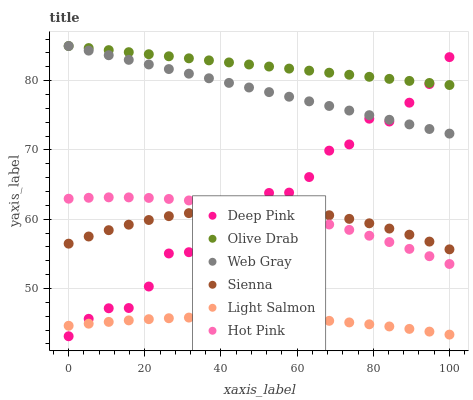Does Light Salmon have the minimum area under the curve?
Answer yes or no. Yes. Does Olive Drab have the maximum area under the curve?
Answer yes or no. Yes. Does Deep Pink have the minimum area under the curve?
Answer yes or no. No. Does Deep Pink have the maximum area under the curve?
Answer yes or no. No. Is Olive Drab the smoothest?
Answer yes or no. Yes. Is Deep Pink the roughest?
Answer yes or no. Yes. Is Hot Pink the smoothest?
Answer yes or no. No. Is Hot Pink the roughest?
Answer yes or no. No. Does Deep Pink have the lowest value?
Answer yes or no. Yes. Does Hot Pink have the lowest value?
Answer yes or no. No. Does Olive Drab have the highest value?
Answer yes or no. Yes. Does Deep Pink have the highest value?
Answer yes or no. No. Is Light Salmon less than Olive Drab?
Answer yes or no. Yes. Is Web Gray greater than Light Salmon?
Answer yes or no. Yes. Does Web Gray intersect Olive Drab?
Answer yes or no. Yes. Is Web Gray less than Olive Drab?
Answer yes or no. No. Is Web Gray greater than Olive Drab?
Answer yes or no. No. Does Light Salmon intersect Olive Drab?
Answer yes or no. No. 